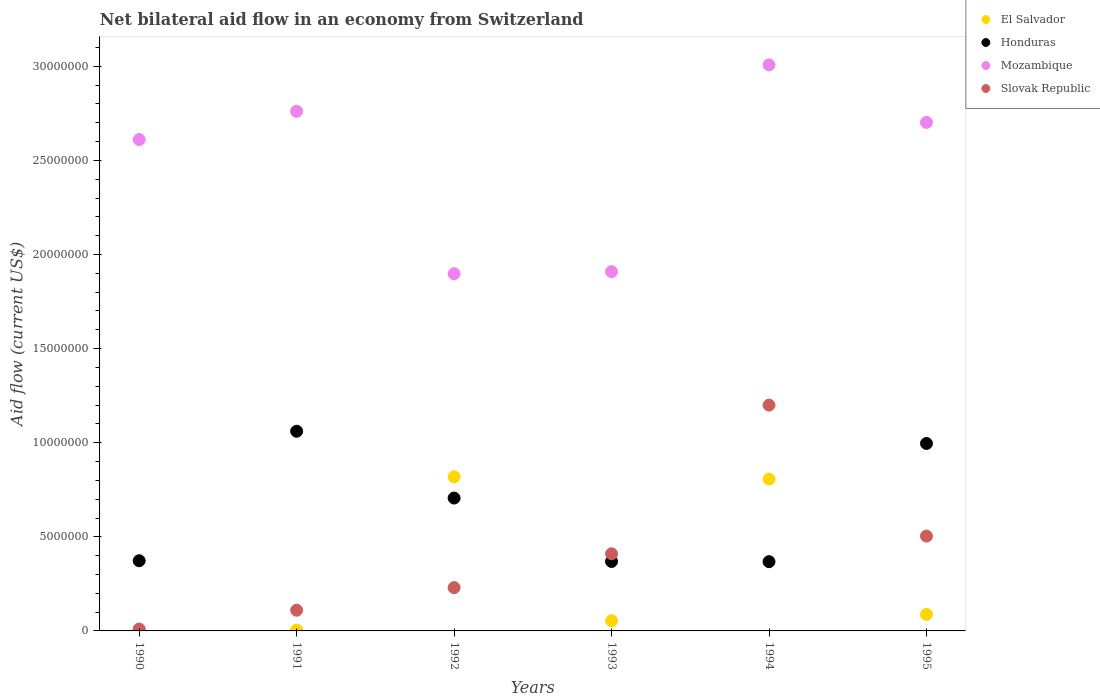Is the number of dotlines equal to the number of legend labels?
Offer a terse response. Yes. Across all years, what is the maximum net bilateral aid flow in El Salvador?
Your response must be concise. 8.19e+06. Across all years, what is the minimum net bilateral aid flow in Slovak Republic?
Provide a succinct answer. 1.00e+05. What is the total net bilateral aid flow in Mozambique in the graph?
Give a very brief answer. 1.49e+08. What is the difference between the net bilateral aid flow in Honduras in 1994 and that in 1995?
Ensure brevity in your answer.  -6.28e+06. What is the difference between the net bilateral aid flow in Mozambique in 1994 and the net bilateral aid flow in El Salvador in 1990?
Provide a succinct answer. 3.00e+07. What is the average net bilateral aid flow in Mozambique per year?
Offer a very short reply. 2.48e+07. In the year 1993, what is the difference between the net bilateral aid flow in Honduras and net bilateral aid flow in Mozambique?
Keep it short and to the point. -1.54e+07. In how many years, is the net bilateral aid flow in Slovak Republic greater than 10000000 US$?
Make the answer very short. 1. What is the ratio of the net bilateral aid flow in Mozambique in 1991 to that in 1994?
Your response must be concise. 0.92. What is the difference between the highest and the second highest net bilateral aid flow in Mozambique?
Offer a terse response. 2.47e+06. What is the difference between the highest and the lowest net bilateral aid flow in Slovak Republic?
Give a very brief answer. 1.19e+07. In how many years, is the net bilateral aid flow in Honduras greater than the average net bilateral aid flow in Honduras taken over all years?
Give a very brief answer. 3. Is the net bilateral aid flow in Honduras strictly less than the net bilateral aid flow in Mozambique over the years?
Provide a succinct answer. Yes. How many dotlines are there?
Your response must be concise. 4. How many years are there in the graph?
Offer a very short reply. 6. Are the values on the major ticks of Y-axis written in scientific E-notation?
Provide a succinct answer. No. Where does the legend appear in the graph?
Your answer should be very brief. Top right. How many legend labels are there?
Your answer should be very brief. 4. What is the title of the graph?
Your answer should be very brief. Net bilateral aid flow in an economy from Switzerland. Does "Mauritania" appear as one of the legend labels in the graph?
Offer a terse response. No. What is the label or title of the X-axis?
Your response must be concise. Years. What is the label or title of the Y-axis?
Your answer should be compact. Aid flow (current US$). What is the Aid flow (current US$) in Honduras in 1990?
Provide a short and direct response. 3.73e+06. What is the Aid flow (current US$) in Mozambique in 1990?
Offer a terse response. 2.61e+07. What is the Aid flow (current US$) in El Salvador in 1991?
Keep it short and to the point. 5.00e+04. What is the Aid flow (current US$) in Honduras in 1991?
Offer a very short reply. 1.06e+07. What is the Aid flow (current US$) of Mozambique in 1991?
Provide a short and direct response. 2.76e+07. What is the Aid flow (current US$) of Slovak Republic in 1991?
Your answer should be very brief. 1.10e+06. What is the Aid flow (current US$) of El Salvador in 1992?
Provide a short and direct response. 8.19e+06. What is the Aid flow (current US$) in Honduras in 1992?
Make the answer very short. 7.06e+06. What is the Aid flow (current US$) in Mozambique in 1992?
Give a very brief answer. 1.90e+07. What is the Aid flow (current US$) of Slovak Republic in 1992?
Provide a succinct answer. 2.30e+06. What is the Aid flow (current US$) of El Salvador in 1993?
Your answer should be compact. 5.40e+05. What is the Aid flow (current US$) in Honduras in 1993?
Give a very brief answer. 3.69e+06. What is the Aid flow (current US$) in Mozambique in 1993?
Your response must be concise. 1.91e+07. What is the Aid flow (current US$) of Slovak Republic in 1993?
Offer a very short reply. 4.10e+06. What is the Aid flow (current US$) of El Salvador in 1994?
Ensure brevity in your answer.  8.07e+06. What is the Aid flow (current US$) of Honduras in 1994?
Provide a short and direct response. 3.68e+06. What is the Aid flow (current US$) of Mozambique in 1994?
Offer a terse response. 3.01e+07. What is the Aid flow (current US$) in El Salvador in 1995?
Your answer should be compact. 8.80e+05. What is the Aid flow (current US$) in Honduras in 1995?
Your answer should be compact. 9.96e+06. What is the Aid flow (current US$) in Mozambique in 1995?
Offer a terse response. 2.70e+07. What is the Aid flow (current US$) of Slovak Republic in 1995?
Your response must be concise. 5.04e+06. Across all years, what is the maximum Aid flow (current US$) in El Salvador?
Ensure brevity in your answer.  8.19e+06. Across all years, what is the maximum Aid flow (current US$) of Honduras?
Your answer should be compact. 1.06e+07. Across all years, what is the maximum Aid flow (current US$) in Mozambique?
Offer a very short reply. 3.01e+07. Across all years, what is the maximum Aid flow (current US$) in Slovak Republic?
Give a very brief answer. 1.20e+07. Across all years, what is the minimum Aid flow (current US$) in El Salvador?
Your answer should be compact. 5.00e+04. Across all years, what is the minimum Aid flow (current US$) of Honduras?
Offer a terse response. 3.68e+06. Across all years, what is the minimum Aid flow (current US$) in Mozambique?
Offer a very short reply. 1.90e+07. Across all years, what is the minimum Aid flow (current US$) in Slovak Republic?
Make the answer very short. 1.00e+05. What is the total Aid flow (current US$) in El Salvador in the graph?
Give a very brief answer. 1.78e+07. What is the total Aid flow (current US$) of Honduras in the graph?
Your answer should be very brief. 3.87e+07. What is the total Aid flow (current US$) of Mozambique in the graph?
Provide a succinct answer. 1.49e+08. What is the total Aid flow (current US$) in Slovak Republic in the graph?
Offer a very short reply. 2.46e+07. What is the difference between the Aid flow (current US$) in Honduras in 1990 and that in 1991?
Provide a short and direct response. -6.88e+06. What is the difference between the Aid flow (current US$) of Mozambique in 1990 and that in 1991?
Provide a short and direct response. -1.50e+06. What is the difference between the Aid flow (current US$) in El Salvador in 1990 and that in 1992?
Your response must be concise. -8.12e+06. What is the difference between the Aid flow (current US$) in Honduras in 1990 and that in 1992?
Ensure brevity in your answer.  -3.33e+06. What is the difference between the Aid flow (current US$) in Mozambique in 1990 and that in 1992?
Your answer should be very brief. 7.13e+06. What is the difference between the Aid flow (current US$) of Slovak Republic in 1990 and that in 1992?
Provide a succinct answer. -2.20e+06. What is the difference between the Aid flow (current US$) of El Salvador in 1990 and that in 1993?
Your response must be concise. -4.70e+05. What is the difference between the Aid flow (current US$) of Honduras in 1990 and that in 1993?
Keep it short and to the point. 4.00e+04. What is the difference between the Aid flow (current US$) of Mozambique in 1990 and that in 1993?
Provide a succinct answer. 7.02e+06. What is the difference between the Aid flow (current US$) in Slovak Republic in 1990 and that in 1993?
Ensure brevity in your answer.  -4.00e+06. What is the difference between the Aid flow (current US$) of El Salvador in 1990 and that in 1994?
Your answer should be very brief. -8.00e+06. What is the difference between the Aid flow (current US$) of Mozambique in 1990 and that in 1994?
Offer a very short reply. -3.97e+06. What is the difference between the Aid flow (current US$) in Slovak Republic in 1990 and that in 1994?
Offer a terse response. -1.19e+07. What is the difference between the Aid flow (current US$) in El Salvador in 1990 and that in 1995?
Ensure brevity in your answer.  -8.10e+05. What is the difference between the Aid flow (current US$) in Honduras in 1990 and that in 1995?
Give a very brief answer. -6.23e+06. What is the difference between the Aid flow (current US$) in Mozambique in 1990 and that in 1995?
Your answer should be compact. -9.10e+05. What is the difference between the Aid flow (current US$) in Slovak Republic in 1990 and that in 1995?
Ensure brevity in your answer.  -4.94e+06. What is the difference between the Aid flow (current US$) in El Salvador in 1991 and that in 1992?
Provide a short and direct response. -8.14e+06. What is the difference between the Aid flow (current US$) of Honduras in 1991 and that in 1992?
Ensure brevity in your answer.  3.55e+06. What is the difference between the Aid flow (current US$) of Mozambique in 1991 and that in 1992?
Ensure brevity in your answer.  8.63e+06. What is the difference between the Aid flow (current US$) in Slovak Republic in 1991 and that in 1992?
Offer a terse response. -1.20e+06. What is the difference between the Aid flow (current US$) of El Salvador in 1991 and that in 1993?
Your answer should be very brief. -4.90e+05. What is the difference between the Aid flow (current US$) in Honduras in 1991 and that in 1993?
Keep it short and to the point. 6.92e+06. What is the difference between the Aid flow (current US$) of Mozambique in 1991 and that in 1993?
Ensure brevity in your answer.  8.52e+06. What is the difference between the Aid flow (current US$) of El Salvador in 1991 and that in 1994?
Your answer should be compact. -8.02e+06. What is the difference between the Aid flow (current US$) of Honduras in 1991 and that in 1994?
Your answer should be very brief. 6.93e+06. What is the difference between the Aid flow (current US$) in Mozambique in 1991 and that in 1994?
Keep it short and to the point. -2.47e+06. What is the difference between the Aid flow (current US$) of Slovak Republic in 1991 and that in 1994?
Make the answer very short. -1.09e+07. What is the difference between the Aid flow (current US$) in El Salvador in 1991 and that in 1995?
Keep it short and to the point. -8.30e+05. What is the difference between the Aid flow (current US$) of Honduras in 1991 and that in 1995?
Offer a terse response. 6.50e+05. What is the difference between the Aid flow (current US$) of Mozambique in 1991 and that in 1995?
Your answer should be compact. 5.90e+05. What is the difference between the Aid flow (current US$) of Slovak Republic in 1991 and that in 1995?
Keep it short and to the point. -3.94e+06. What is the difference between the Aid flow (current US$) in El Salvador in 1992 and that in 1993?
Your response must be concise. 7.65e+06. What is the difference between the Aid flow (current US$) in Honduras in 1992 and that in 1993?
Keep it short and to the point. 3.37e+06. What is the difference between the Aid flow (current US$) of Slovak Republic in 1992 and that in 1993?
Offer a very short reply. -1.80e+06. What is the difference between the Aid flow (current US$) in Honduras in 1992 and that in 1994?
Make the answer very short. 3.38e+06. What is the difference between the Aid flow (current US$) in Mozambique in 1992 and that in 1994?
Your answer should be very brief. -1.11e+07. What is the difference between the Aid flow (current US$) in Slovak Republic in 1992 and that in 1994?
Your response must be concise. -9.70e+06. What is the difference between the Aid flow (current US$) of El Salvador in 1992 and that in 1995?
Provide a short and direct response. 7.31e+06. What is the difference between the Aid flow (current US$) of Honduras in 1992 and that in 1995?
Offer a terse response. -2.90e+06. What is the difference between the Aid flow (current US$) of Mozambique in 1992 and that in 1995?
Offer a terse response. -8.04e+06. What is the difference between the Aid flow (current US$) in Slovak Republic in 1992 and that in 1995?
Your answer should be compact. -2.74e+06. What is the difference between the Aid flow (current US$) in El Salvador in 1993 and that in 1994?
Keep it short and to the point. -7.53e+06. What is the difference between the Aid flow (current US$) in Mozambique in 1993 and that in 1994?
Give a very brief answer. -1.10e+07. What is the difference between the Aid flow (current US$) of Slovak Republic in 1993 and that in 1994?
Offer a very short reply. -7.90e+06. What is the difference between the Aid flow (current US$) of El Salvador in 1993 and that in 1995?
Provide a short and direct response. -3.40e+05. What is the difference between the Aid flow (current US$) of Honduras in 1993 and that in 1995?
Give a very brief answer. -6.27e+06. What is the difference between the Aid flow (current US$) of Mozambique in 1993 and that in 1995?
Give a very brief answer. -7.93e+06. What is the difference between the Aid flow (current US$) in Slovak Republic in 1993 and that in 1995?
Keep it short and to the point. -9.40e+05. What is the difference between the Aid flow (current US$) of El Salvador in 1994 and that in 1995?
Your answer should be compact. 7.19e+06. What is the difference between the Aid flow (current US$) in Honduras in 1994 and that in 1995?
Make the answer very short. -6.28e+06. What is the difference between the Aid flow (current US$) in Mozambique in 1994 and that in 1995?
Provide a short and direct response. 3.06e+06. What is the difference between the Aid flow (current US$) of Slovak Republic in 1994 and that in 1995?
Offer a very short reply. 6.96e+06. What is the difference between the Aid flow (current US$) of El Salvador in 1990 and the Aid flow (current US$) of Honduras in 1991?
Make the answer very short. -1.05e+07. What is the difference between the Aid flow (current US$) in El Salvador in 1990 and the Aid flow (current US$) in Mozambique in 1991?
Keep it short and to the point. -2.75e+07. What is the difference between the Aid flow (current US$) of El Salvador in 1990 and the Aid flow (current US$) of Slovak Republic in 1991?
Offer a terse response. -1.03e+06. What is the difference between the Aid flow (current US$) in Honduras in 1990 and the Aid flow (current US$) in Mozambique in 1991?
Your response must be concise. -2.39e+07. What is the difference between the Aid flow (current US$) in Honduras in 1990 and the Aid flow (current US$) in Slovak Republic in 1991?
Keep it short and to the point. 2.63e+06. What is the difference between the Aid flow (current US$) of Mozambique in 1990 and the Aid flow (current US$) of Slovak Republic in 1991?
Offer a very short reply. 2.50e+07. What is the difference between the Aid flow (current US$) in El Salvador in 1990 and the Aid flow (current US$) in Honduras in 1992?
Offer a very short reply. -6.99e+06. What is the difference between the Aid flow (current US$) of El Salvador in 1990 and the Aid flow (current US$) of Mozambique in 1992?
Your response must be concise. -1.89e+07. What is the difference between the Aid flow (current US$) in El Salvador in 1990 and the Aid flow (current US$) in Slovak Republic in 1992?
Provide a short and direct response. -2.23e+06. What is the difference between the Aid flow (current US$) in Honduras in 1990 and the Aid flow (current US$) in Mozambique in 1992?
Offer a terse response. -1.52e+07. What is the difference between the Aid flow (current US$) in Honduras in 1990 and the Aid flow (current US$) in Slovak Republic in 1992?
Keep it short and to the point. 1.43e+06. What is the difference between the Aid flow (current US$) in Mozambique in 1990 and the Aid flow (current US$) in Slovak Republic in 1992?
Offer a very short reply. 2.38e+07. What is the difference between the Aid flow (current US$) in El Salvador in 1990 and the Aid flow (current US$) in Honduras in 1993?
Keep it short and to the point. -3.62e+06. What is the difference between the Aid flow (current US$) of El Salvador in 1990 and the Aid flow (current US$) of Mozambique in 1993?
Provide a succinct answer. -1.90e+07. What is the difference between the Aid flow (current US$) in El Salvador in 1990 and the Aid flow (current US$) in Slovak Republic in 1993?
Give a very brief answer. -4.03e+06. What is the difference between the Aid flow (current US$) of Honduras in 1990 and the Aid flow (current US$) of Mozambique in 1993?
Ensure brevity in your answer.  -1.54e+07. What is the difference between the Aid flow (current US$) of Honduras in 1990 and the Aid flow (current US$) of Slovak Republic in 1993?
Your response must be concise. -3.70e+05. What is the difference between the Aid flow (current US$) in Mozambique in 1990 and the Aid flow (current US$) in Slovak Republic in 1993?
Ensure brevity in your answer.  2.20e+07. What is the difference between the Aid flow (current US$) of El Salvador in 1990 and the Aid flow (current US$) of Honduras in 1994?
Your answer should be very brief. -3.61e+06. What is the difference between the Aid flow (current US$) of El Salvador in 1990 and the Aid flow (current US$) of Mozambique in 1994?
Your answer should be compact. -3.00e+07. What is the difference between the Aid flow (current US$) of El Salvador in 1990 and the Aid flow (current US$) of Slovak Republic in 1994?
Ensure brevity in your answer.  -1.19e+07. What is the difference between the Aid flow (current US$) in Honduras in 1990 and the Aid flow (current US$) in Mozambique in 1994?
Ensure brevity in your answer.  -2.64e+07. What is the difference between the Aid flow (current US$) in Honduras in 1990 and the Aid flow (current US$) in Slovak Republic in 1994?
Keep it short and to the point. -8.27e+06. What is the difference between the Aid flow (current US$) of Mozambique in 1990 and the Aid flow (current US$) of Slovak Republic in 1994?
Provide a short and direct response. 1.41e+07. What is the difference between the Aid flow (current US$) of El Salvador in 1990 and the Aid flow (current US$) of Honduras in 1995?
Your response must be concise. -9.89e+06. What is the difference between the Aid flow (current US$) of El Salvador in 1990 and the Aid flow (current US$) of Mozambique in 1995?
Give a very brief answer. -2.70e+07. What is the difference between the Aid flow (current US$) of El Salvador in 1990 and the Aid flow (current US$) of Slovak Republic in 1995?
Your answer should be very brief. -4.97e+06. What is the difference between the Aid flow (current US$) of Honduras in 1990 and the Aid flow (current US$) of Mozambique in 1995?
Keep it short and to the point. -2.33e+07. What is the difference between the Aid flow (current US$) of Honduras in 1990 and the Aid flow (current US$) of Slovak Republic in 1995?
Your answer should be compact. -1.31e+06. What is the difference between the Aid flow (current US$) in Mozambique in 1990 and the Aid flow (current US$) in Slovak Republic in 1995?
Make the answer very short. 2.11e+07. What is the difference between the Aid flow (current US$) of El Salvador in 1991 and the Aid flow (current US$) of Honduras in 1992?
Your answer should be compact. -7.01e+06. What is the difference between the Aid flow (current US$) in El Salvador in 1991 and the Aid flow (current US$) in Mozambique in 1992?
Your answer should be compact. -1.89e+07. What is the difference between the Aid flow (current US$) of El Salvador in 1991 and the Aid flow (current US$) of Slovak Republic in 1992?
Your answer should be compact. -2.25e+06. What is the difference between the Aid flow (current US$) in Honduras in 1991 and the Aid flow (current US$) in Mozambique in 1992?
Give a very brief answer. -8.37e+06. What is the difference between the Aid flow (current US$) in Honduras in 1991 and the Aid flow (current US$) in Slovak Republic in 1992?
Your response must be concise. 8.31e+06. What is the difference between the Aid flow (current US$) in Mozambique in 1991 and the Aid flow (current US$) in Slovak Republic in 1992?
Your answer should be very brief. 2.53e+07. What is the difference between the Aid flow (current US$) of El Salvador in 1991 and the Aid flow (current US$) of Honduras in 1993?
Your response must be concise. -3.64e+06. What is the difference between the Aid flow (current US$) of El Salvador in 1991 and the Aid flow (current US$) of Mozambique in 1993?
Your answer should be compact. -1.90e+07. What is the difference between the Aid flow (current US$) of El Salvador in 1991 and the Aid flow (current US$) of Slovak Republic in 1993?
Provide a succinct answer. -4.05e+06. What is the difference between the Aid flow (current US$) in Honduras in 1991 and the Aid flow (current US$) in Mozambique in 1993?
Keep it short and to the point. -8.48e+06. What is the difference between the Aid flow (current US$) in Honduras in 1991 and the Aid flow (current US$) in Slovak Republic in 1993?
Provide a succinct answer. 6.51e+06. What is the difference between the Aid flow (current US$) in Mozambique in 1991 and the Aid flow (current US$) in Slovak Republic in 1993?
Keep it short and to the point. 2.35e+07. What is the difference between the Aid flow (current US$) of El Salvador in 1991 and the Aid flow (current US$) of Honduras in 1994?
Keep it short and to the point. -3.63e+06. What is the difference between the Aid flow (current US$) of El Salvador in 1991 and the Aid flow (current US$) of Mozambique in 1994?
Give a very brief answer. -3.00e+07. What is the difference between the Aid flow (current US$) of El Salvador in 1991 and the Aid flow (current US$) of Slovak Republic in 1994?
Your answer should be very brief. -1.20e+07. What is the difference between the Aid flow (current US$) in Honduras in 1991 and the Aid flow (current US$) in Mozambique in 1994?
Your answer should be compact. -1.95e+07. What is the difference between the Aid flow (current US$) in Honduras in 1991 and the Aid flow (current US$) in Slovak Republic in 1994?
Offer a terse response. -1.39e+06. What is the difference between the Aid flow (current US$) of Mozambique in 1991 and the Aid flow (current US$) of Slovak Republic in 1994?
Provide a short and direct response. 1.56e+07. What is the difference between the Aid flow (current US$) of El Salvador in 1991 and the Aid flow (current US$) of Honduras in 1995?
Your answer should be very brief. -9.91e+06. What is the difference between the Aid flow (current US$) in El Salvador in 1991 and the Aid flow (current US$) in Mozambique in 1995?
Your answer should be compact. -2.70e+07. What is the difference between the Aid flow (current US$) of El Salvador in 1991 and the Aid flow (current US$) of Slovak Republic in 1995?
Ensure brevity in your answer.  -4.99e+06. What is the difference between the Aid flow (current US$) in Honduras in 1991 and the Aid flow (current US$) in Mozambique in 1995?
Provide a short and direct response. -1.64e+07. What is the difference between the Aid flow (current US$) in Honduras in 1991 and the Aid flow (current US$) in Slovak Republic in 1995?
Your answer should be very brief. 5.57e+06. What is the difference between the Aid flow (current US$) of Mozambique in 1991 and the Aid flow (current US$) of Slovak Republic in 1995?
Your answer should be very brief. 2.26e+07. What is the difference between the Aid flow (current US$) in El Salvador in 1992 and the Aid flow (current US$) in Honduras in 1993?
Give a very brief answer. 4.50e+06. What is the difference between the Aid flow (current US$) of El Salvador in 1992 and the Aid flow (current US$) of Mozambique in 1993?
Provide a short and direct response. -1.09e+07. What is the difference between the Aid flow (current US$) in El Salvador in 1992 and the Aid flow (current US$) in Slovak Republic in 1993?
Provide a short and direct response. 4.09e+06. What is the difference between the Aid flow (current US$) of Honduras in 1992 and the Aid flow (current US$) of Mozambique in 1993?
Provide a short and direct response. -1.20e+07. What is the difference between the Aid flow (current US$) of Honduras in 1992 and the Aid flow (current US$) of Slovak Republic in 1993?
Your response must be concise. 2.96e+06. What is the difference between the Aid flow (current US$) of Mozambique in 1992 and the Aid flow (current US$) of Slovak Republic in 1993?
Offer a terse response. 1.49e+07. What is the difference between the Aid flow (current US$) in El Salvador in 1992 and the Aid flow (current US$) in Honduras in 1994?
Ensure brevity in your answer.  4.51e+06. What is the difference between the Aid flow (current US$) in El Salvador in 1992 and the Aid flow (current US$) in Mozambique in 1994?
Your answer should be very brief. -2.19e+07. What is the difference between the Aid flow (current US$) in El Salvador in 1992 and the Aid flow (current US$) in Slovak Republic in 1994?
Your answer should be compact. -3.81e+06. What is the difference between the Aid flow (current US$) in Honduras in 1992 and the Aid flow (current US$) in Mozambique in 1994?
Give a very brief answer. -2.30e+07. What is the difference between the Aid flow (current US$) in Honduras in 1992 and the Aid flow (current US$) in Slovak Republic in 1994?
Offer a very short reply. -4.94e+06. What is the difference between the Aid flow (current US$) of Mozambique in 1992 and the Aid flow (current US$) of Slovak Republic in 1994?
Your answer should be very brief. 6.98e+06. What is the difference between the Aid flow (current US$) of El Salvador in 1992 and the Aid flow (current US$) of Honduras in 1995?
Provide a short and direct response. -1.77e+06. What is the difference between the Aid flow (current US$) in El Salvador in 1992 and the Aid flow (current US$) in Mozambique in 1995?
Make the answer very short. -1.88e+07. What is the difference between the Aid flow (current US$) of El Salvador in 1992 and the Aid flow (current US$) of Slovak Republic in 1995?
Give a very brief answer. 3.15e+06. What is the difference between the Aid flow (current US$) of Honduras in 1992 and the Aid flow (current US$) of Mozambique in 1995?
Provide a short and direct response. -2.00e+07. What is the difference between the Aid flow (current US$) in Honduras in 1992 and the Aid flow (current US$) in Slovak Republic in 1995?
Offer a terse response. 2.02e+06. What is the difference between the Aid flow (current US$) in Mozambique in 1992 and the Aid flow (current US$) in Slovak Republic in 1995?
Keep it short and to the point. 1.39e+07. What is the difference between the Aid flow (current US$) in El Salvador in 1993 and the Aid flow (current US$) in Honduras in 1994?
Your answer should be compact. -3.14e+06. What is the difference between the Aid flow (current US$) of El Salvador in 1993 and the Aid flow (current US$) of Mozambique in 1994?
Ensure brevity in your answer.  -2.95e+07. What is the difference between the Aid flow (current US$) in El Salvador in 1993 and the Aid flow (current US$) in Slovak Republic in 1994?
Your answer should be very brief. -1.15e+07. What is the difference between the Aid flow (current US$) in Honduras in 1993 and the Aid flow (current US$) in Mozambique in 1994?
Your answer should be compact. -2.64e+07. What is the difference between the Aid flow (current US$) of Honduras in 1993 and the Aid flow (current US$) of Slovak Republic in 1994?
Your answer should be very brief. -8.31e+06. What is the difference between the Aid flow (current US$) of Mozambique in 1993 and the Aid flow (current US$) of Slovak Republic in 1994?
Your response must be concise. 7.09e+06. What is the difference between the Aid flow (current US$) of El Salvador in 1993 and the Aid flow (current US$) of Honduras in 1995?
Ensure brevity in your answer.  -9.42e+06. What is the difference between the Aid flow (current US$) of El Salvador in 1993 and the Aid flow (current US$) of Mozambique in 1995?
Ensure brevity in your answer.  -2.65e+07. What is the difference between the Aid flow (current US$) of El Salvador in 1993 and the Aid flow (current US$) of Slovak Republic in 1995?
Your answer should be compact. -4.50e+06. What is the difference between the Aid flow (current US$) of Honduras in 1993 and the Aid flow (current US$) of Mozambique in 1995?
Your response must be concise. -2.33e+07. What is the difference between the Aid flow (current US$) in Honduras in 1993 and the Aid flow (current US$) in Slovak Republic in 1995?
Your answer should be compact. -1.35e+06. What is the difference between the Aid flow (current US$) of Mozambique in 1993 and the Aid flow (current US$) of Slovak Republic in 1995?
Your answer should be very brief. 1.40e+07. What is the difference between the Aid flow (current US$) of El Salvador in 1994 and the Aid flow (current US$) of Honduras in 1995?
Keep it short and to the point. -1.89e+06. What is the difference between the Aid flow (current US$) of El Salvador in 1994 and the Aid flow (current US$) of Mozambique in 1995?
Ensure brevity in your answer.  -1.90e+07. What is the difference between the Aid flow (current US$) in El Salvador in 1994 and the Aid flow (current US$) in Slovak Republic in 1995?
Offer a terse response. 3.03e+06. What is the difference between the Aid flow (current US$) of Honduras in 1994 and the Aid flow (current US$) of Mozambique in 1995?
Offer a very short reply. -2.33e+07. What is the difference between the Aid flow (current US$) of Honduras in 1994 and the Aid flow (current US$) of Slovak Republic in 1995?
Give a very brief answer. -1.36e+06. What is the difference between the Aid flow (current US$) of Mozambique in 1994 and the Aid flow (current US$) of Slovak Republic in 1995?
Offer a very short reply. 2.50e+07. What is the average Aid flow (current US$) in El Salvador per year?
Your answer should be compact. 2.97e+06. What is the average Aid flow (current US$) in Honduras per year?
Give a very brief answer. 6.46e+06. What is the average Aid flow (current US$) of Mozambique per year?
Provide a short and direct response. 2.48e+07. What is the average Aid flow (current US$) in Slovak Republic per year?
Offer a very short reply. 4.11e+06. In the year 1990, what is the difference between the Aid flow (current US$) of El Salvador and Aid flow (current US$) of Honduras?
Your response must be concise. -3.66e+06. In the year 1990, what is the difference between the Aid flow (current US$) of El Salvador and Aid flow (current US$) of Mozambique?
Keep it short and to the point. -2.60e+07. In the year 1990, what is the difference between the Aid flow (current US$) in Honduras and Aid flow (current US$) in Mozambique?
Ensure brevity in your answer.  -2.24e+07. In the year 1990, what is the difference between the Aid flow (current US$) of Honduras and Aid flow (current US$) of Slovak Republic?
Provide a short and direct response. 3.63e+06. In the year 1990, what is the difference between the Aid flow (current US$) in Mozambique and Aid flow (current US$) in Slovak Republic?
Make the answer very short. 2.60e+07. In the year 1991, what is the difference between the Aid flow (current US$) in El Salvador and Aid flow (current US$) in Honduras?
Your answer should be compact. -1.06e+07. In the year 1991, what is the difference between the Aid flow (current US$) of El Salvador and Aid flow (current US$) of Mozambique?
Your answer should be very brief. -2.76e+07. In the year 1991, what is the difference between the Aid flow (current US$) of El Salvador and Aid flow (current US$) of Slovak Republic?
Ensure brevity in your answer.  -1.05e+06. In the year 1991, what is the difference between the Aid flow (current US$) of Honduras and Aid flow (current US$) of Mozambique?
Offer a very short reply. -1.70e+07. In the year 1991, what is the difference between the Aid flow (current US$) of Honduras and Aid flow (current US$) of Slovak Republic?
Ensure brevity in your answer.  9.51e+06. In the year 1991, what is the difference between the Aid flow (current US$) in Mozambique and Aid flow (current US$) in Slovak Republic?
Your response must be concise. 2.65e+07. In the year 1992, what is the difference between the Aid flow (current US$) of El Salvador and Aid flow (current US$) of Honduras?
Provide a succinct answer. 1.13e+06. In the year 1992, what is the difference between the Aid flow (current US$) of El Salvador and Aid flow (current US$) of Mozambique?
Your answer should be very brief. -1.08e+07. In the year 1992, what is the difference between the Aid flow (current US$) of El Salvador and Aid flow (current US$) of Slovak Republic?
Ensure brevity in your answer.  5.89e+06. In the year 1992, what is the difference between the Aid flow (current US$) in Honduras and Aid flow (current US$) in Mozambique?
Your answer should be very brief. -1.19e+07. In the year 1992, what is the difference between the Aid flow (current US$) in Honduras and Aid flow (current US$) in Slovak Republic?
Ensure brevity in your answer.  4.76e+06. In the year 1992, what is the difference between the Aid flow (current US$) in Mozambique and Aid flow (current US$) in Slovak Republic?
Offer a terse response. 1.67e+07. In the year 1993, what is the difference between the Aid flow (current US$) of El Salvador and Aid flow (current US$) of Honduras?
Offer a terse response. -3.15e+06. In the year 1993, what is the difference between the Aid flow (current US$) of El Salvador and Aid flow (current US$) of Mozambique?
Ensure brevity in your answer.  -1.86e+07. In the year 1993, what is the difference between the Aid flow (current US$) in El Salvador and Aid flow (current US$) in Slovak Republic?
Make the answer very short. -3.56e+06. In the year 1993, what is the difference between the Aid flow (current US$) of Honduras and Aid flow (current US$) of Mozambique?
Offer a very short reply. -1.54e+07. In the year 1993, what is the difference between the Aid flow (current US$) in Honduras and Aid flow (current US$) in Slovak Republic?
Offer a very short reply. -4.10e+05. In the year 1993, what is the difference between the Aid flow (current US$) of Mozambique and Aid flow (current US$) of Slovak Republic?
Provide a succinct answer. 1.50e+07. In the year 1994, what is the difference between the Aid flow (current US$) of El Salvador and Aid flow (current US$) of Honduras?
Keep it short and to the point. 4.39e+06. In the year 1994, what is the difference between the Aid flow (current US$) of El Salvador and Aid flow (current US$) of Mozambique?
Offer a terse response. -2.20e+07. In the year 1994, what is the difference between the Aid flow (current US$) of El Salvador and Aid flow (current US$) of Slovak Republic?
Keep it short and to the point. -3.93e+06. In the year 1994, what is the difference between the Aid flow (current US$) of Honduras and Aid flow (current US$) of Mozambique?
Your answer should be compact. -2.64e+07. In the year 1994, what is the difference between the Aid flow (current US$) in Honduras and Aid flow (current US$) in Slovak Republic?
Your answer should be compact. -8.32e+06. In the year 1994, what is the difference between the Aid flow (current US$) in Mozambique and Aid flow (current US$) in Slovak Republic?
Offer a terse response. 1.81e+07. In the year 1995, what is the difference between the Aid flow (current US$) of El Salvador and Aid flow (current US$) of Honduras?
Ensure brevity in your answer.  -9.08e+06. In the year 1995, what is the difference between the Aid flow (current US$) of El Salvador and Aid flow (current US$) of Mozambique?
Offer a terse response. -2.61e+07. In the year 1995, what is the difference between the Aid flow (current US$) of El Salvador and Aid flow (current US$) of Slovak Republic?
Keep it short and to the point. -4.16e+06. In the year 1995, what is the difference between the Aid flow (current US$) in Honduras and Aid flow (current US$) in Mozambique?
Your answer should be very brief. -1.71e+07. In the year 1995, what is the difference between the Aid flow (current US$) of Honduras and Aid flow (current US$) of Slovak Republic?
Your response must be concise. 4.92e+06. In the year 1995, what is the difference between the Aid flow (current US$) in Mozambique and Aid flow (current US$) in Slovak Republic?
Offer a very short reply. 2.20e+07. What is the ratio of the Aid flow (current US$) in El Salvador in 1990 to that in 1991?
Give a very brief answer. 1.4. What is the ratio of the Aid flow (current US$) in Honduras in 1990 to that in 1991?
Offer a terse response. 0.35. What is the ratio of the Aid flow (current US$) of Mozambique in 1990 to that in 1991?
Your answer should be compact. 0.95. What is the ratio of the Aid flow (current US$) of Slovak Republic in 1990 to that in 1991?
Your answer should be compact. 0.09. What is the ratio of the Aid flow (current US$) in El Salvador in 1990 to that in 1992?
Make the answer very short. 0.01. What is the ratio of the Aid flow (current US$) in Honduras in 1990 to that in 1992?
Provide a short and direct response. 0.53. What is the ratio of the Aid flow (current US$) in Mozambique in 1990 to that in 1992?
Your response must be concise. 1.38. What is the ratio of the Aid flow (current US$) of Slovak Republic in 1990 to that in 1992?
Your answer should be very brief. 0.04. What is the ratio of the Aid flow (current US$) of El Salvador in 1990 to that in 1993?
Your response must be concise. 0.13. What is the ratio of the Aid flow (current US$) in Honduras in 1990 to that in 1993?
Ensure brevity in your answer.  1.01. What is the ratio of the Aid flow (current US$) of Mozambique in 1990 to that in 1993?
Give a very brief answer. 1.37. What is the ratio of the Aid flow (current US$) in Slovak Republic in 1990 to that in 1993?
Your answer should be compact. 0.02. What is the ratio of the Aid flow (current US$) in El Salvador in 1990 to that in 1994?
Keep it short and to the point. 0.01. What is the ratio of the Aid flow (current US$) in Honduras in 1990 to that in 1994?
Offer a terse response. 1.01. What is the ratio of the Aid flow (current US$) of Mozambique in 1990 to that in 1994?
Ensure brevity in your answer.  0.87. What is the ratio of the Aid flow (current US$) of Slovak Republic in 1990 to that in 1994?
Your answer should be compact. 0.01. What is the ratio of the Aid flow (current US$) in El Salvador in 1990 to that in 1995?
Your answer should be very brief. 0.08. What is the ratio of the Aid flow (current US$) in Honduras in 1990 to that in 1995?
Make the answer very short. 0.37. What is the ratio of the Aid flow (current US$) of Mozambique in 1990 to that in 1995?
Ensure brevity in your answer.  0.97. What is the ratio of the Aid flow (current US$) of Slovak Republic in 1990 to that in 1995?
Make the answer very short. 0.02. What is the ratio of the Aid flow (current US$) of El Salvador in 1991 to that in 1992?
Offer a very short reply. 0.01. What is the ratio of the Aid flow (current US$) in Honduras in 1991 to that in 1992?
Offer a terse response. 1.5. What is the ratio of the Aid flow (current US$) of Mozambique in 1991 to that in 1992?
Offer a very short reply. 1.45. What is the ratio of the Aid flow (current US$) of Slovak Republic in 1991 to that in 1992?
Keep it short and to the point. 0.48. What is the ratio of the Aid flow (current US$) in El Salvador in 1991 to that in 1993?
Give a very brief answer. 0.09. What is the ratio of the Aid flow (current US$) of Honduras in 1991 to that in 1993?
Give a very brief answer. 2.88. What is the ratio of the Aid flow (current US$) of Mozambique in 1991 to that in 1993?
Keep it short and to the point. 1.45. What is the ratio of the Aid flow (current US$) of Slovak Republic in 1991 to that in 1993?
Your answer should be compact. 0.27. What is the ratio of the Aid flow (current US$) in El Salvador in 1991 to that in 1994?
Give a very brief answer. 0.01. What is the ratio of the Aid flow (current US$) of Honduras in 1991 to that in 1994?
Offer a terse response. 2.88. What is the ratio of the Aid flow (current US$) of Mozambique in 1991 to that in 1994?
Your answer should be very brief. 0.92. What is the ratio of the Aid flow (current US$) of Slovak Republic in 1991 to that in 1994?
Give a very brief answer. 0.09. What is the ratio of the Aid flow (current US$) of El Salvador in 1991 to that in 1995?
Keep it short and to the point. 0.06. What is the ratio of the Aid flow (current US$) of Honduras in 1991 to that in 1995?
Keep it short and to the point. 1.07. What is the ratio of the Aid flow (current US$) in Mozambique in 1991 to that in 1995?
Provide a succinct answer. 1.02. What is the ratio of the Aid flow (current US$) in Slovak Republic in 1991 to that in 1995?
Offer a very short reply. 0.22. What is the ratio of the Aid flow (current US$) of El Salvador in 1992 to that in 1993?
Offer a very short reply. 15.17. What is the ratio of the Aid flow (current US$) of Honduras in 1992 to that in 1993?
Offer a terse response. 1.91. What is the ratio of the Aid flow (current US$) in Slovak Republic in 1992 to that in 1993?
Your answer should be very brief. 0.56. What is the ratio of the Aid flow (current US$) in El Salvador in 1992 to that in 1994?
Your answer should be very brief. 1.01. What is the ratio of the Aid flow (current US$) of Honduras in 1992 to that in 1994?
Ensure brevity in your answer.  1.92. What is the ratio of the Aid flow (current US$) in Mozambique in 1992 to that in 1994?
Give a very brief answer. 0.63. What is the ratio of the Aid flow (current US$) of Slovak Republic in 1992 to that in 1994?
Offer a terse response. 0.19. What is the ratio of the Aid flow (current US$) in El Salvador in 1992 to that in 1995?
Give a very brief answer. 9.31. What is the ratio of the Aid flow (current US$) in Honduras in 1992 to that in 1995?
Your answer should be very brief. 0.71. What is the ratio of the Aid flow (current US$) of Mozambique in 1992 to that in 1995?
Your answer should be compact. 0.7. What is the ratio of the Aid flow (current US$) of Slovak Republic in 1992 to that in 1995?
Provide a succinct answer. 0.46. What is the ratio of the Aid flow (current US$) of El Salvador in 1993 to that in 1994?
Keep it short and to the point. 0.07. What is the ratio of the Aid flow (current US$) of Mozambique in 1993 to that in 1994?
Provide a succinct answer. 0.63. What is the ratio of the Aid flow (current US$) in Slovak Republic in 1993 to that in 1994?
Provide a short and direct response. 0.34. What is the ratio of the Aid flow (current US$) of El Salvador in 1993 to that in 1995?
Your answer should be very brief. 0.61. What is the ratio of the Aid flow (current US$) in Honduras in 1993 to that in 1995?
Provide a succinct answer. 0.37. What is the ratio of the Aid flow (current US$) of Mozambique in 1993 to that in 1995?
Your response must be concise. 0.71. What is the ratio of the Aid flow (current US$) of Slovak Republic in 1993 to that in 1995?
Keep it short and to the point. 0.81. What is the ratio of the Aid flow (current US$) in El Salvador in 1994 to that in 1995?
Your response must be concise. 9.17. What is the ratio of the Aid flow (current US$) of Honduras in 1994 to that in 1995?
Provide a short and direct response. 0.37. What is the ratio of the Aid flow (current US$) in Mozambique in 1994 to that in 1995?
Keep it short and to the point. 1.11. What is the ratio of the Aid flow (current US$) of Slovak Republic in 1994 to that in 1995?
Ensure brevity in your answer.  2.38. What is the difference between the highest and the second highest Aid flow (current US$) in Honduras?
Offer a very short reply. 6.50e+05. What is the difference between the highest and the second highest Aid flow (current US$) in Mozambique?
Ensure brevity in your answer.  2.47e+06. What is the difference between the highest and the second highest Aid flow (current US$) of Slovak Republic?
Provide a succinct answer. 6.96e+06. What is the difference between the highest and the lowest Aid flow (current US$) in El Salvador?
Make the answer very short. 8.14e+06. What is the difference between the highest and the lowest Aid flow (current US$) of Honduras?
Offer a very short reply. 6.93e+06. What is the difference between the highest and the lowest Aid flow (current US$) of Mozambique?
Ensure brevity in your answer.  1.11e+07. What is the difference between the highest and the lowest Aid flow (current US$) in Slovak Republic?
Your response must be concise. 1.19e+07. 